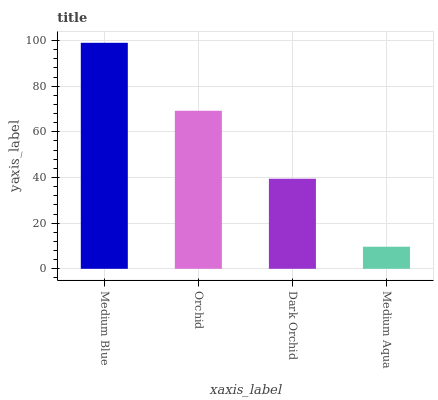Is Orchid the minimum?
Answer yes or no. No. Is Orchid the maximum?
Answer yes or no. No. Is Medium Blue greater than Orchid?
Answer yes or no. Yes. Is Orchid less than Medium Blue?
Answer yes or no. Yes. Is Orchid greater than Medium Blue?
Answer yes or no. No. Is Medium Blue less than Orchid?
Answer yes or no. No. Is Orchid the high median?
Answer yes or no. Yes. Is Dark Orchid the low median?
Answer yes or no. Yes. Is Medium Blue the high median?
Answer yes or no. No. Is Medium Blue the low median?
Answer yes or no. No. 